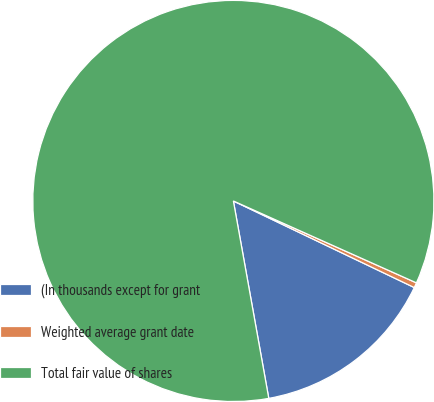Convert chart to OTSL. <chart><loc_0><loc_0><loc_500><loc_500><pie_chart><fcel>(In thousands except for grant<fcel>Weighted average grant date<fcel>Total fair value of shares<nl><fcel>15.07%<fcel>0.41%<fcel>84.52%<nl></chart> 